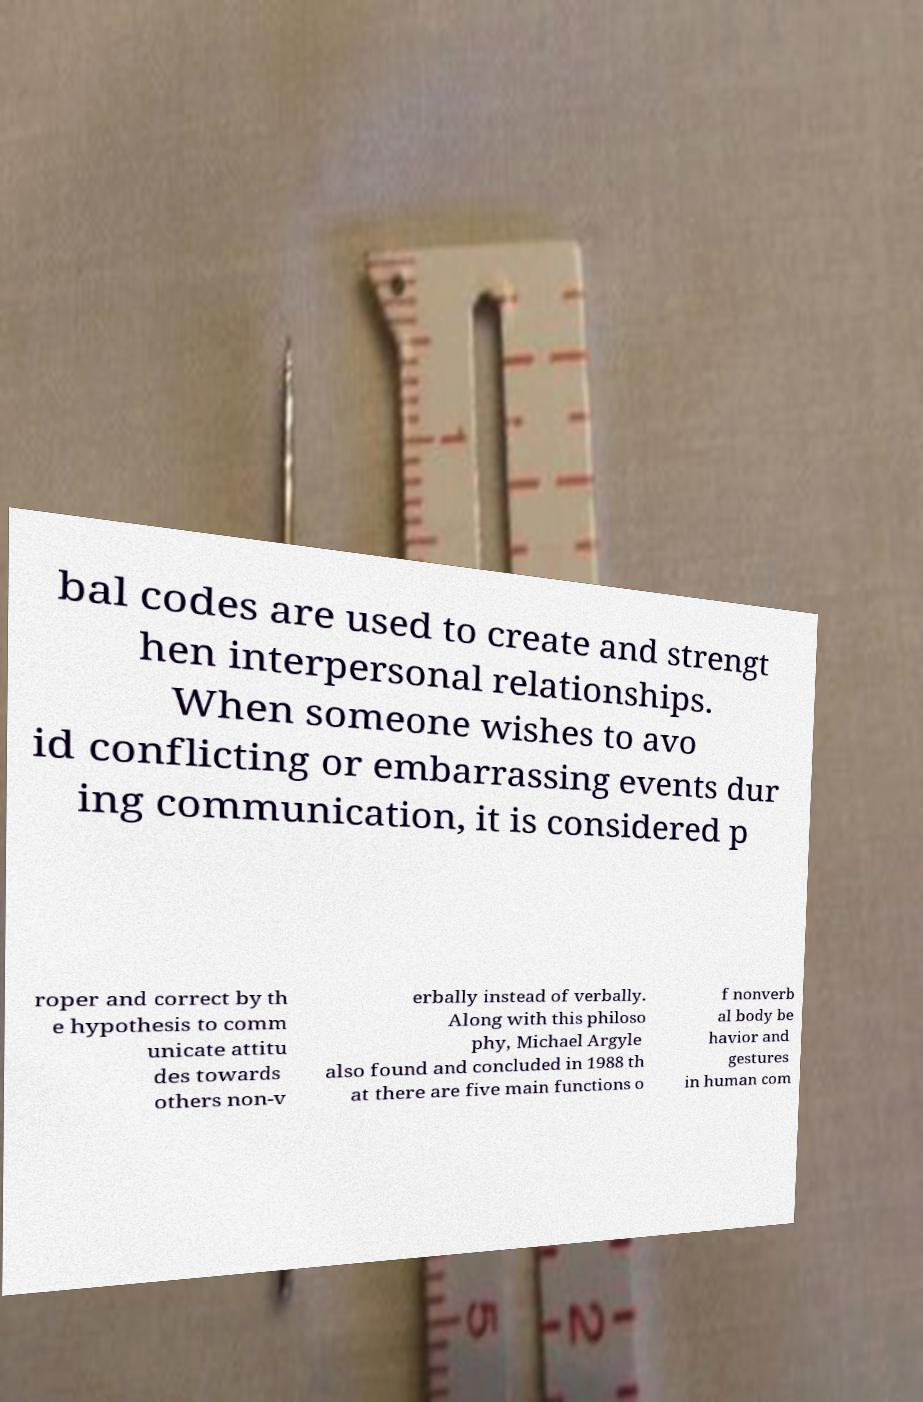Can you read and provide the text displayed in the image?This photo seems to have some interesting text. Can you extract and type it out for me? bal codes are used to create and strengt hen interpersonal relationships. When someone wishes to avo id conflicting or embarrassing events dur ing communication, it is considered p roper and correct by th e hypothesis to comm unicate attitu des towards others non-v erbally instead of verbally. Along with this philoso phy, Michael Argyle also found and concluded in 1988 th at there are five main functions o f nonverb al body be havior and gestures in human com 